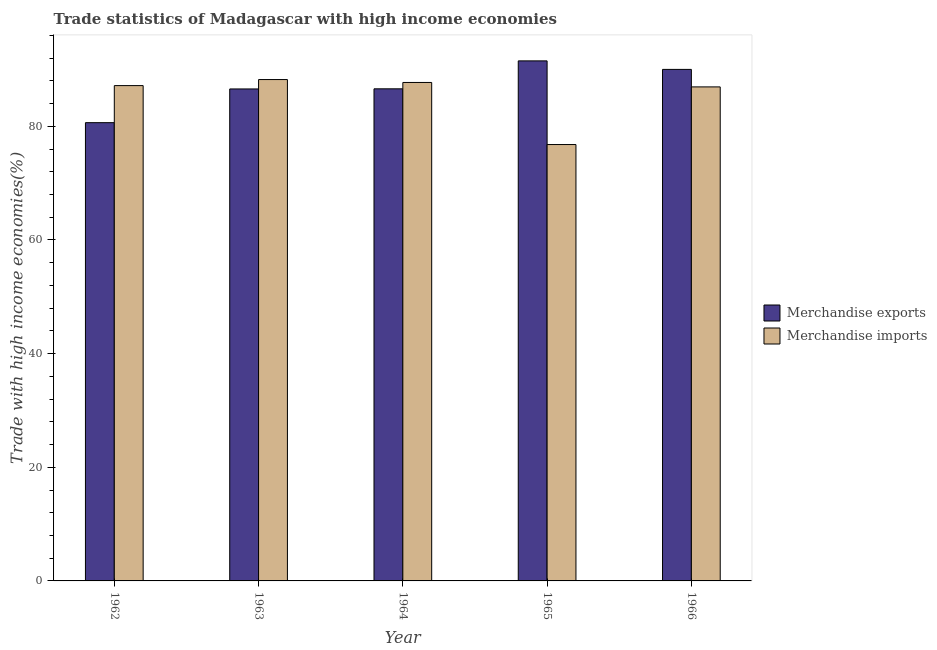How many different coloured bars are there?
Provide a short and direct response. 2. How many groups of bars are there?
Your answer should be very brief. 5. Are the number of bars on each tick of the X-axis equal?
Your answer should be very brief. Yes. How many bars are there on the 5th tick from the left?
Your response must be concise. 2. How many bars are there on the 5th tick from the right?
Offer a terse response. 2. In how many cases, is the number of bars for a given year not equal to the number of legend labels?
Your response must be concise. 0. What is the merchandise exports in 1964?
Your response must be concise. 86.61. Across all years, what is the maximum merchandise imports?
Your answer should be compact. 88.24. Across all years, what is the minimum merchandise exports?
Give a very brief answer. 80.65. In which year was the merchandise exports maximum?
Provide a succinct answer. 1965. What is the total merchandise exports in the graph?
Your answer should be very brief. 435.38. What is the difference between the merchandise exports in 1963 and that in 1964?
Provide a short and direct response. -0.02. What is the difference between the merchandise exports in 1963 and the merchandise imports in 1964?
Your answer should be very brief. -0.02. What is the average merchandise exports per year?
Provide a short and direct response. 87.08. In how many years, is the merchandise imports greater than 92 %?
Provide a short and direct response. 0. What is the ratio of the merchandise imports in 1962 to that in 1966?
Provide a succinct answer. 1. Is the merchandise exports in 1962 less than that in 1964?
Give a very brief answer. Yes. What is the difference between the highest and the second highest merchandise exports?
Provide a short and direct response. 1.5. What is the difference between the highest and the lowest merchandise exports?
Give a very brief answer. 10.87. In how many years, is the merchandise imports greater than the average merchandise imports taken over all years?
Give a very brief answer. 4. How many bars are there?
Offer a terse response. 10. Are all the bars in the graph horizontal?
Offer a very short reply. No. How many years are there in the graph?
Your answer should be very brief. 5. What is the difference between two consecutive major ticks on the Y-axis?
Provide a short and direct response. 20. Where does the legend appear in the graph?
Ensure brevity in your answer.  Center right. How are the legend labels stacked?
Your response must be concise. Vertical. What is the title of the graph?
Make the answer very short. Trade statistics of Madagascar with high income economies. Does "Subsidies" appear as one of the legend labels in the graph?
Offer a terse response. No. What is the label or title of the X-axis?
Offer a very short reply. Year. What is the label or title of the Y-axis?
Provide a short and direct response. Trade with high income economies(%). What is the Trade with high income economies(%) of Merchandise exports in 1962?
Ensure brevity in your answer.  80.65. What is the Trade with high income economies(%) of Merchandise imports in 1962?
Your response must be concise. 87.17. What is the Trade with high income economies(%) of Merchandise exports in 1963?
Make the answer very short. 86.58. What is the Trade with high income economies(%) of Merchandise imports in 1963?
Ensure brevity in your answer.  88.24. What is the Trade with high income economies(%) in Merchandise exports in 1964?
Make the answer very short. 86.61. What is the Trade with high income economies(%) in Merchandise imports in 1964?
Your answer should be very brief. 87.72. What is the Trade with high income economies(%) of Merchandise exports in 1965?
Provide a short and direct response. 91.52. What is the Trade with high income economies(%) of Merchandise imports in 1965?
Ensure brevity in your answer.  76.8. What is the Trade with high income economies(%) in Merchandise exports in 1966?
Ensure brevity in your answer.  90.02. What is the Trade with high income economies(%) in Merchandise imports in 1966?
Make the answer very short. 86.94. Across all years, what is the maximum Trade with high income economies(%) of Merchandise exports?
Provide a succinct answer. 91.52. Across all years, what is the maximum Trade with high income economies(%) in Merchandise imports?
Make the answer very short. 88.24. Across all years, what is the minimum Trade with high income economies(%) in Merchandise exports?
Your response must be concise. 80.65. Across all years, what is the minimum Trade with high income economies(%) in Merchandise imports?
Offer a terse response. 76.8. What is the total Trade with high income economies(%) of Merchandise exports in the graph?
Provide a short and direct response. 435.38. What is the total Trade with high income economies(%) of Merchandise imports in the graph?
Your answer should be compact. 426.87. What is the difference between the Trade with high income economies(%) in Merchandise exports in 1962 and that in 1963?
Make the answer very short. -5.93. What is the difference between the Trade with high income economies(%) of Merchandise imports in 1962 and that in 1963?
Your answer should be very brief. -1.06. What is the difference between the Trade with high income economies(%) in Merchandise exports in 1962 and that in 1964?
Your answer should be compact. -5.96. What is the difference between the Trade with high income economies(%) in Merchandise imports in 1962 and that in 1964?
Make the answer very short. -0.55. What is the difference between the Trade with high income economies(%) in Merchandise exports in 1962 and that in 1965?
Give a very brief answer. -10.87. What is the difference between the Trade with high income economies(%) of Merchandise imports in 1962 and that in 1965?
Provide a short and direct response. 10.37. What is the difference between the Trade with high income economies(%) of Merchandise exports in 1962 and that in 1966?
Ensure brevity in your answer.  -9.37. What is the difference between the Trade with high income economies(%) in Merchandise imports in 1962 and that in 1966?
Keep it short and to the point. 0.23. What is the difference between the Trade with high income economies(%) in Merchandise exports in 1963 and that in 1964?
Keep it short and to the point. -0.02. What is the difference between the Trade with high income economies(%) of Merchandise imports in 1963 and that in 1964?
Offer a terse response. 0.51. What is the difference between the Trade with high income economies(%) in Merchandise exports in 1963 and that in 1965?
Ensure brevity in your answer.  -4.94. What is the difference between the Trade with high income economies(%) of Merchandise imports in 1963 and that in 1965?
Make the answer very short. 11.44. What is the difference between the Trade with high income economies(%) in Merchandise exports in 1963 and that in 1966?
Your answer should be compact. -3.44. What is the difference between the Trade with high income economies(%) in Merchandise imports in 1963 and that in 1966?
Provide a succinct answer. 1.29. What is the difference between the Trade with high income economies(%) in Merchandise exports in 1964 and that in 1965?
Give a very brief answer. -4.92. What is the difference between the Trade with high income economies(%) of Merchandise imports in 1964 and that in 1965?
Your answer should be compact. 10.93. What is the difference between the Trade with high income economies(%) in Merchandise exports in 1964 and that in 1966?
Keep it short and to the point. -3.42. What is the difference between the Trade with high income economies(%) of Merchandise imports in 1964 and that in 1966?
Give a very brief answer. 0.78. What is the difference between the Trade with high income economies(%) in Merchandise exports in 1965 and that in 1966?
Your answer should be compact. 1.5. What is the difference between the Trade with high income economies(%) of Merchandise imports in 1965 and that in 1966?
Your answer should be very brief. -10.14. What is the difference between the Trade with high income economies(%) in Merchandise exports in 1962 and the Trade with high income economies(%) in Merchandise imports in 1963?
Ensure brevity in your answer.  -7.59. What is the difference between the Trade with high income economies(%) of Merchandise exports in 1962 and the Trade with high income economies(%) of Merchandise imports in 1964?
Provide a short and direct response. -7.07. What is the difference between the Trade with high income economies(%) in Merchandise exports in 1962 and the Trade with high income economies(%) in Merchandise imports in 1965?
Provide a succinct answer. 3.85. What is the difference between the Trade with high income economies(%) of Merchandise exports in 1962 and the Trade with high income economies(%) of Merchandise imports in 1966?
Make the answer very short. -6.29. What is the difference between the Trade with high income economies(%) in Merchandise exports in 1963 and the Trade with high income economies(%) in Merchandise imports in 1964?
Your response must be concise. -1.14. What is the difference between the Trade with high income economies(%) of Merchandise exports in 1963 and the Trade with high income economies(%) of Merchandise imports in 1965?
Your answer should be compact. 9.78. What is the difference between the Trade with high income economies(%) of Merchandise exports in 1963 and the Trade with high income economies(%) of Merchandise imports in 1966?
Offer a very short reply. -0.36. What is the difference between the Trade with high income economies(%) in Merchandise exports in 1964 and the Trade with high income economies(%) in Merchandise imports in 1965?
Provide a succinct answer. 9.81. What is the difference between the Trade with high income economies(%) in Merchandise exports in 1964 and the Trade with high income economies(%) in Merchandise imports in 1966?
Offer a very short reply. -0.34. What is the difference between the Trade with high income economies(%) in Merchandise exports in 1965 and the Trade with high income economies(%) in Merchandise imports in 1966?
Your answer should be compact. 4.58. What is the average Trade with high income economies(%) of Merchandise exports per year?
Your answer should be very brief. 87.08. What is the average Trade with high income economies(%) in Merchandise imports per year?
Make the answer very short. 85.37. In the year 1962, what is the difference between the Trade with high income economies(%) of Merchandise exports and Trade with high income economies(%) of Merchandise imports?
Make the answer very short. -6.52. In the year 1963, what is the difference between the Trade with high income economies(%) of Merchandise exports and Trade with high income economies(%) of Merchandise imports?
Ensure brevity in your answer.  -1.65. In the year 1964, what is the difference between the Trade with high income economies(%) of Merchandise exports and Trade with high income economies(%) of Merchandise imports?
Your answer should be compact. -1.12. In the year 1965, what is the difference between the Trade with high income economies(%) in Merchandise exports and Trade with high income economies(%) in Merchandise imports?
Your answer should be very brief. 14.72. In the year 1966, what is the difference between the Trade with high income economies(%) in Merchandise exports and Trade with high income economies(%) in Merchandise imports?
Your answer should be very brief. 3.08. What is the ratio of the Trade with high income economies(%) in Merchandise exports in 1962 to that in 1963?
Your answer should be compact. 0.93. What is the ratio of the Trade with high income economies(%) in Merchandise imports in 1962 to that in 1963?
Give a very brief answer. 0.99. What is the ratio of the Trade with high income economies(%) of Merchandise exports in 1962 to that in 1964?
Keep it short and to the point. 0.93. What is the ratio of the Trade with high income economies(%) of Merchandise exports in 1962 to that in 1965?
Provide a short and direct response. 0.88. What is the ratio of the Trade with high income economies(%) of Merchandise imports in 1962 to that in 1965?
Offer a terse response. 1.14. What is the ratio of the Trade with high income economies(%) in Merchandise exports in 1962 to that in 1966?
Your answer should be very brief. 0.9. What is the ratio of the Trade with high income economies(%) of Merchandise imports in 1962 to that in 1966?
Provide a succinct answer. 1. What is the ratio of the Trade with high income economies(%) in Merchandise exports in 1963 to that in 1964?
Provide a short and direct response. 1. What is the ratio of the Trade with high income economies(%) of Merchandise imports in 1963 to that in 1964?
Make the answer very short. 1.01. What is the ratio of the Trade with high income economies(%) in Merchandise exports in 1963 to that in 1965?
Provide a short and direct response. 0.95. What is the ratio of the Trade with high income economies(%) of Merchandise imports in 1963 to that in 1965?
Your response must be concise. 1.15. What is the ratio of the Trade with high income economies(%) in Merchandise exports in 1963 to that in 1966?
Provide a succinct answer. 0.96. What is the ratio of the Trade with high income economies(%) of Merchandise imports in 1963 to that in 1966?
Provide a short and direct response. 1.01. What is the ratio of the Trade with high income economies(%) of Merchandise exports in 1964 to that in 1965?
Make the answer very short. 0.95. What is the ratio of the Trade with high income economies(%) of Merchandise imports in 1964 to that in 1965?
Give a very brief answer. 1.14. What is the ratio of the Trade with high income economies(%) in Merchandise exports in 1965 to that in 1966?
Ensure brevity in your answer.  1.02. What is the ratio of the Trade with high income economies(%) of Merchandise imports in 1965 to that in 1966?
Your response must be concise. 0.88. What is the difference between the highest and the second highest Trade with high income economies(%) in Merchandise exports?
Offer a terse response. 1.5. What is the difference between the highest and the second highest Trade with high income economies(%) of Merchandise imports?
Provide a succinct answer. 0.51. What is the difference between the highest and the lowest Trade with high income economies(%) of Merchandise exports?
Provide a short and direct response. 10.87. What is the difference between the highest and the lowest Trade with high income economies(%) in Merchandise imports?
Provide a succinct answer. 11.44. 